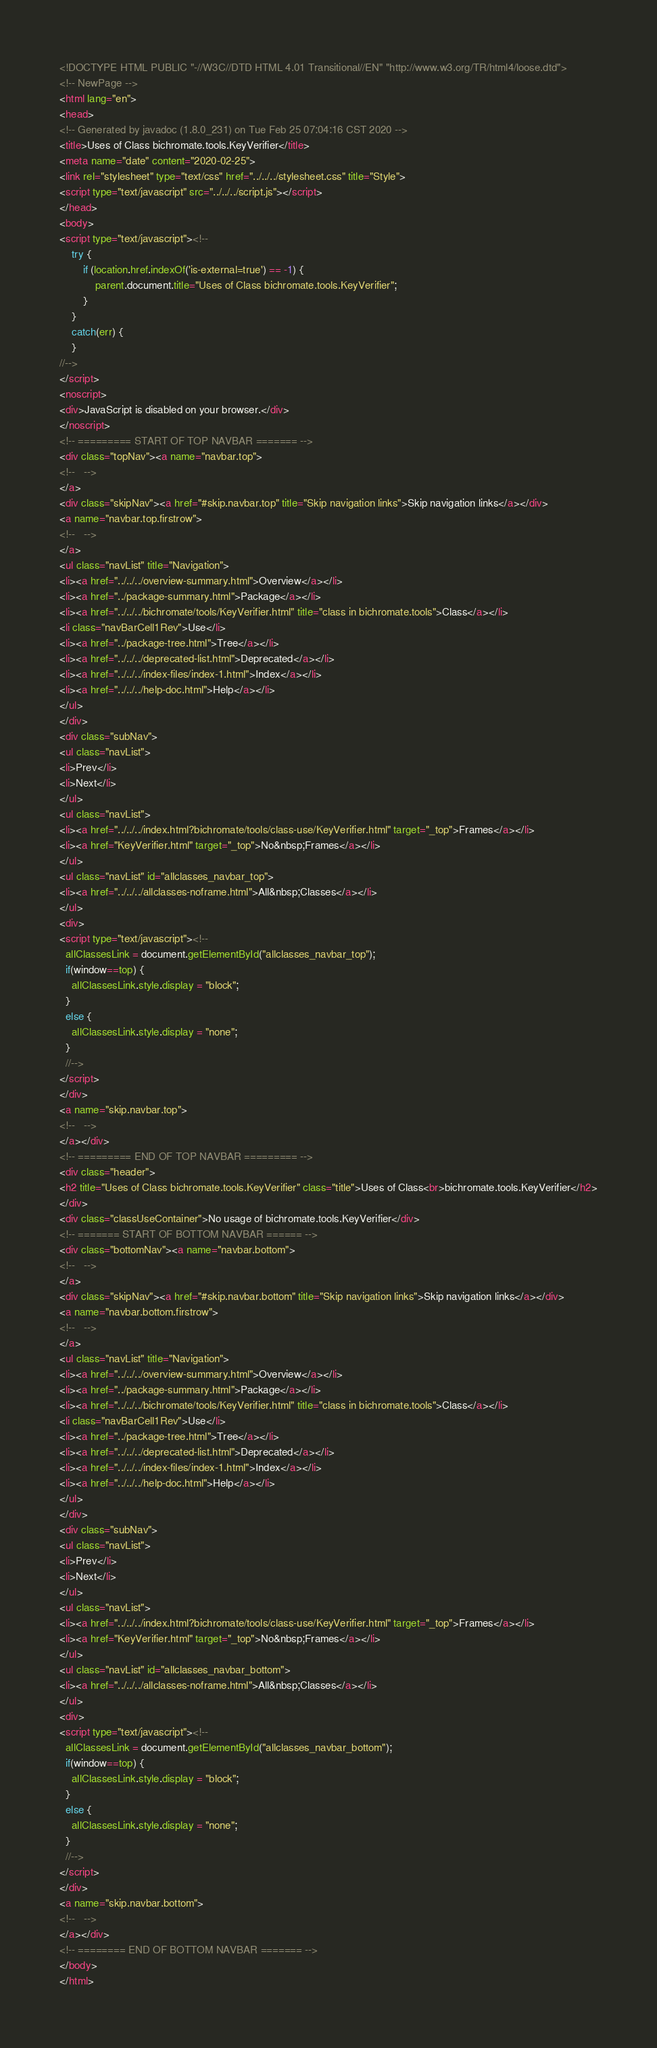Convert code to text. <code><loc_0><loc_0><loc_500><loc_500><_HTML_><!DOCTYPE HTML PUBLIC "-//W3C//DTD HTML 4.01 Transitional//EN" "http://www.w3.org/TR/html4/loose.dtd">
<!-- NewPage -->
<html lang="en">
<head>
<!-- Generated by javadoc (1.8.0_231) on Tue Feb 25 07:04:16 CST 2020 -->
<title>Uses of Class bichromate.tools.KeyVerifier</title>
<meta name="date" content="2020-02-25">
<link rel="stylesheet" type="text/css" href="../../../stylesheet.css" title="Style">
<script type="text/javascript" src="../../../script.js"></script>
</head>
<body>
<script type="text/javascript"><!--
    try {
        if (location.href.indexOf('is-external=true') == -1) {
            parent.document.title="Uses of Class bichromate.tools.KeyVerifier";
        }
    }
    catch(err) {
    }
//-->
</script>
<noscript>
<div>JavaScript is disabled on your browser.</div>
</noscript>
<!-- ========= START OF TOP NAVBAR ======= -->
<div class="topNav"><a name="navbar.top">
<!--   -->
</a>
<div class="skipNav"><a href="#skip.navbar.top" title="Skip navigation links">Skip navigation links</a></div>
<a name="navbar.top.firstrow">
<!--   -->
</a>
<ul class="navList" title="Navigation">
<li><a href="../../../overview-summary.html">Overview</a></li>
<li><a href="../package-summary.html">Package</a></li>
<li><a href="../../../bichromate/tools/KeyVerifier.html" title="class in bichromate.tools">Class</a></li>
<li class="navBarCell1Rev">Use</li>
<li><a href="../package-tree.html">Tree</a></li>
<li><a href="../../../deprecated-list.html">Deprecated</a></li>
<li><a href="../../../index-files/index-1.html">Index</a></li>
<li><a href="../../../help-doc.html">Help</a></li>
</ul>
</div>
<div class="subNav">
<ul class="navList">
<li>Prev</li>
<li>Next</li>
</ul>
<ul class="navList">
<li><a href="../../../index.html?bichromate/tools/class-use/KeyVerifier.html" target="_top">Frames</a></li>
<li><a href="KeyVerifier.html" target="_top">No&nbsp;Frames</a></li>
</ul>
<ul class="navList" id="allclasses_navbar_top">
<li><a href="../../../allclasses-noframe.html">All&nbsp;Classes</a></li>
</ul>
<div>
<script type="text/javascript"><!--
  allClassesLink = document.getElementById("allclasses_navbar_top");
  if(window==top) {
    allClassesLink.style.display = "block";
  }
  else {
    allClassesLink.style.display = "none";
  }
  //-->
</script>
</div>
<a name="skip.navbar.top">
<!--   -->
</a></div>
<!-- ========= END OF TOP NAVBAR ========= -->
<div class="header">
<h2 title="Uses of Class bichromate.tools.KeyVerifier" class="title">Uses of Class<br>bichromate.tools.KeyVerifier</h2>
</div>
<div class="classUseContainer">No usage of bichromate.tools.KeyVerifier</div>
<!-- ======= START OF BOTTOM NAVBAR ====== -->
<div class="bottomNav"><a name="navbar.bottom">
<!--   -->
</a>
<div class="skipNav"><a href="#skip.navbar.bottom" title="Skip navigation links">Skip navigation links</a></div>
<a name="navbar.bottom.firstrow">
<!--   -->
</a>
<ul class="navList" title="Navigation">
<li><a href="../../../overview-summary.html">Overview</a></li>
<li><a href="../package-summary.html">Package</a></li>
<li><a href="../../../bichromate/tools/KeyVerifier.html" title="class in bichromate.tools">Class</a></li>
<li class="navBarCell1Rev">Use</li>
<li><a href="../package-tree.html">Tree</a></li>
<li><a href="../../../deprecated-list.html">Deprecated</a></li>
<li><a href="../../../index-files/index-1.html">Index</a></li>
<li><a href="../../../help-doc.html">Help</a></li>
</ul>
</div>
<div class="subNav">
<ul class="navList">
<li>Prev</li>
<li>Next</li>
</ul>
<ul class="navList">
<li><a href="../../../index.html?bichromate/tools/class-use/KeyVerifier.html" target="_top">Frames</a></li>
<li><a href="KeyVerifier.html" target="_top">No&nbsp;Frames</a></li>
</ul>
<ul class="navList" id="allclasses_navbar_bottom">
<li><a href="../../../allclasses-noframe.html">All&nbsp;Classes</a></li>
</ul>
<div>
<script type="text/javascript"><!--
  allClassesLink = document.getElementById("allclasses_navbar_bottom");
  if(window==top) {
    allClassesLink.style.display = "block";
  }
  else {
    allClassesLink.style.display = "none";
  }
  //-->
</script>
</div>
<a name="skip.navbar.bottom">
<!--   -->
</a></div>
<!-- ======== END OF BOTTOM NAVBAR ======= -->
</body>
</html>
</code> 